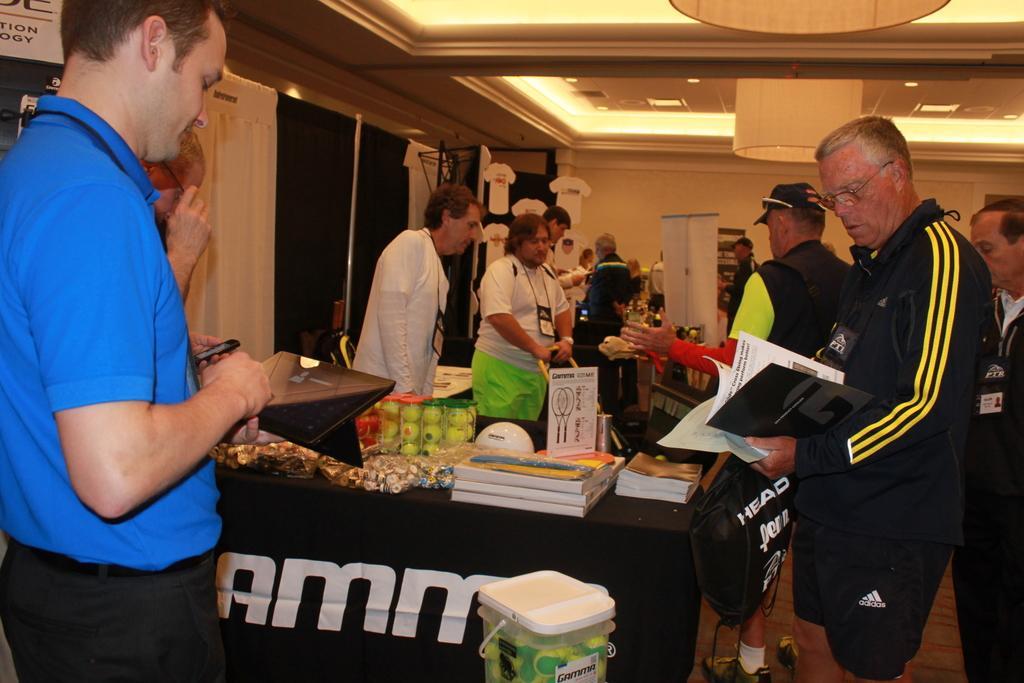Describe this image in one or two sentences. In this picture we can see some people are standing in front of the table on it few objects are placed. 